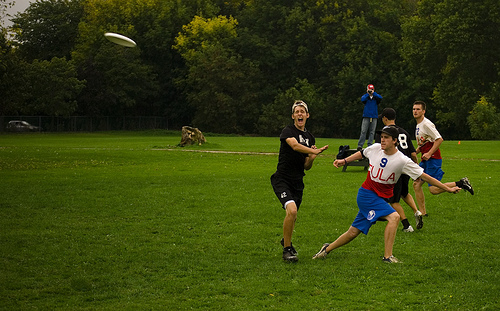Please transcribe the text information in this image. 9 ULA 8 